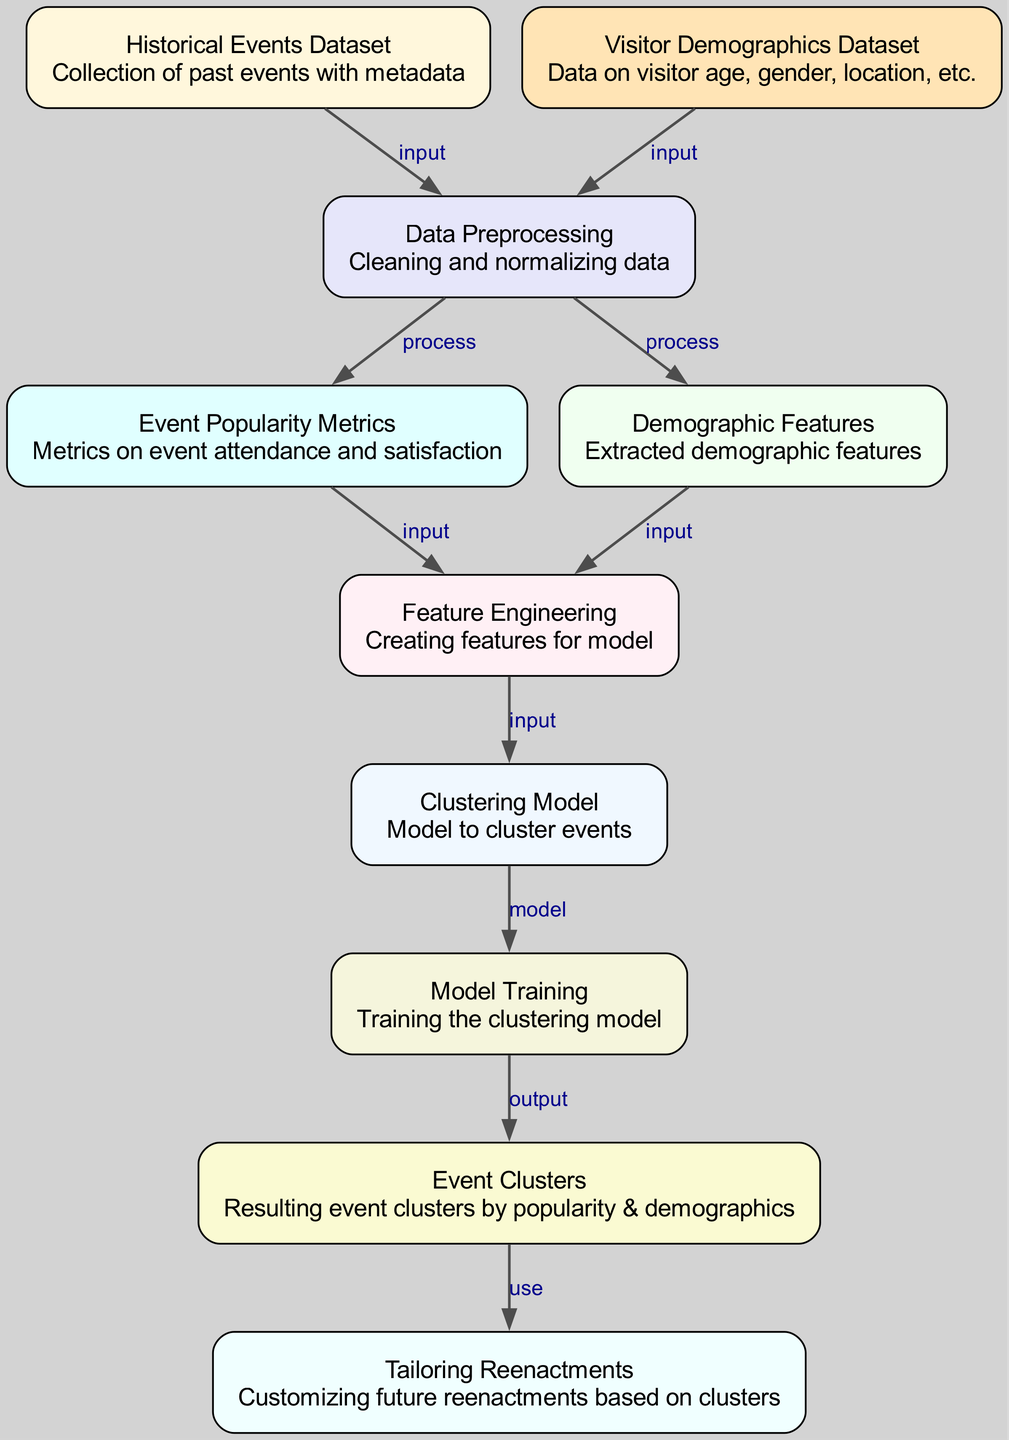What are the two main datasets used in this diagram? The diagram features two primary datasets, one labeled as "Historical Events Dataset" and the other as "Visitor Demographics Dataset." These datasets are represented as nodes, showing that they serve as inputs for further processing.
Answer: Historical Events Dataset, Visitor Demographics Dataset How many nodes are present in the diagram? To determine the total number of nodes, we can count each distinct element outlined in the data. The nodes listed are historical_events, visitor_data, preprocessing, event_popularity, demographic_features, feature_engineering, clustering_model, training, clusters, and tailoring_reenactments, which totals ten.
Answer: 10 Which node directly connects to the “Tailoring Reenactments” node? The "Tailoring Reenactments" node is sourced from the "Event Clusters" node, as indicated by a directed edge leading into it, which signifies that the clusters are utilized to tailor the reenactments.
Answer: Event Clusters What process follows the data preprocessing step? After the preprocessing step, the data feeds into two processes: "Event Popularity Metrics" and "Demographic Features," indicating that these metrics are derived after the initial data cleaning and normalization.
Answer: Event Popularity Metrics, Demographic Features What is the final output of the clustering model? The output of the clustering model, as indicated by the directed edge flowing from the "Training" node, results in "Event Clusters," which serve as the final stage of the model training process.
Answer: Event Clusters Explain the flow of data from the historical events to the tailoring of reenactments. The flow begins with the "Historical Events Dataset" feeding into the "Data Preprocessing" node. After preprocessing, the processed data splits into metrics for event popularity and demographic features, both feeding into "Feature Engineering." This generates inputs for the "Clustering Model," which, after training, produces output in the form of "Event Clusters." Finally, these clusters inform the customization of reenactments.
Answer: Historical Events Dataset → Data Preprocessing → Event Popularity Metrics, Demographic Features → Feature Engineering → Clustering Model → Training → Event Clusters → Tailoring Reenactments Which node has the role of model training in this workflow? The "Model Training" node represents the specific step in the machine learning workflow where the clustering model is refined and adjusted based on the input features, indicating its pivotal role in developing the model.
Answer: Model Training What inputs are needed for the feature engineering process? The feature engineering process requires inputs from two nodes: "Event Popularity Metrics" and "Demographic Features," which provide the relevant data for creating new features utilized in the clustering model.
Answer: Event Popularity Metrics, Demographic Features 